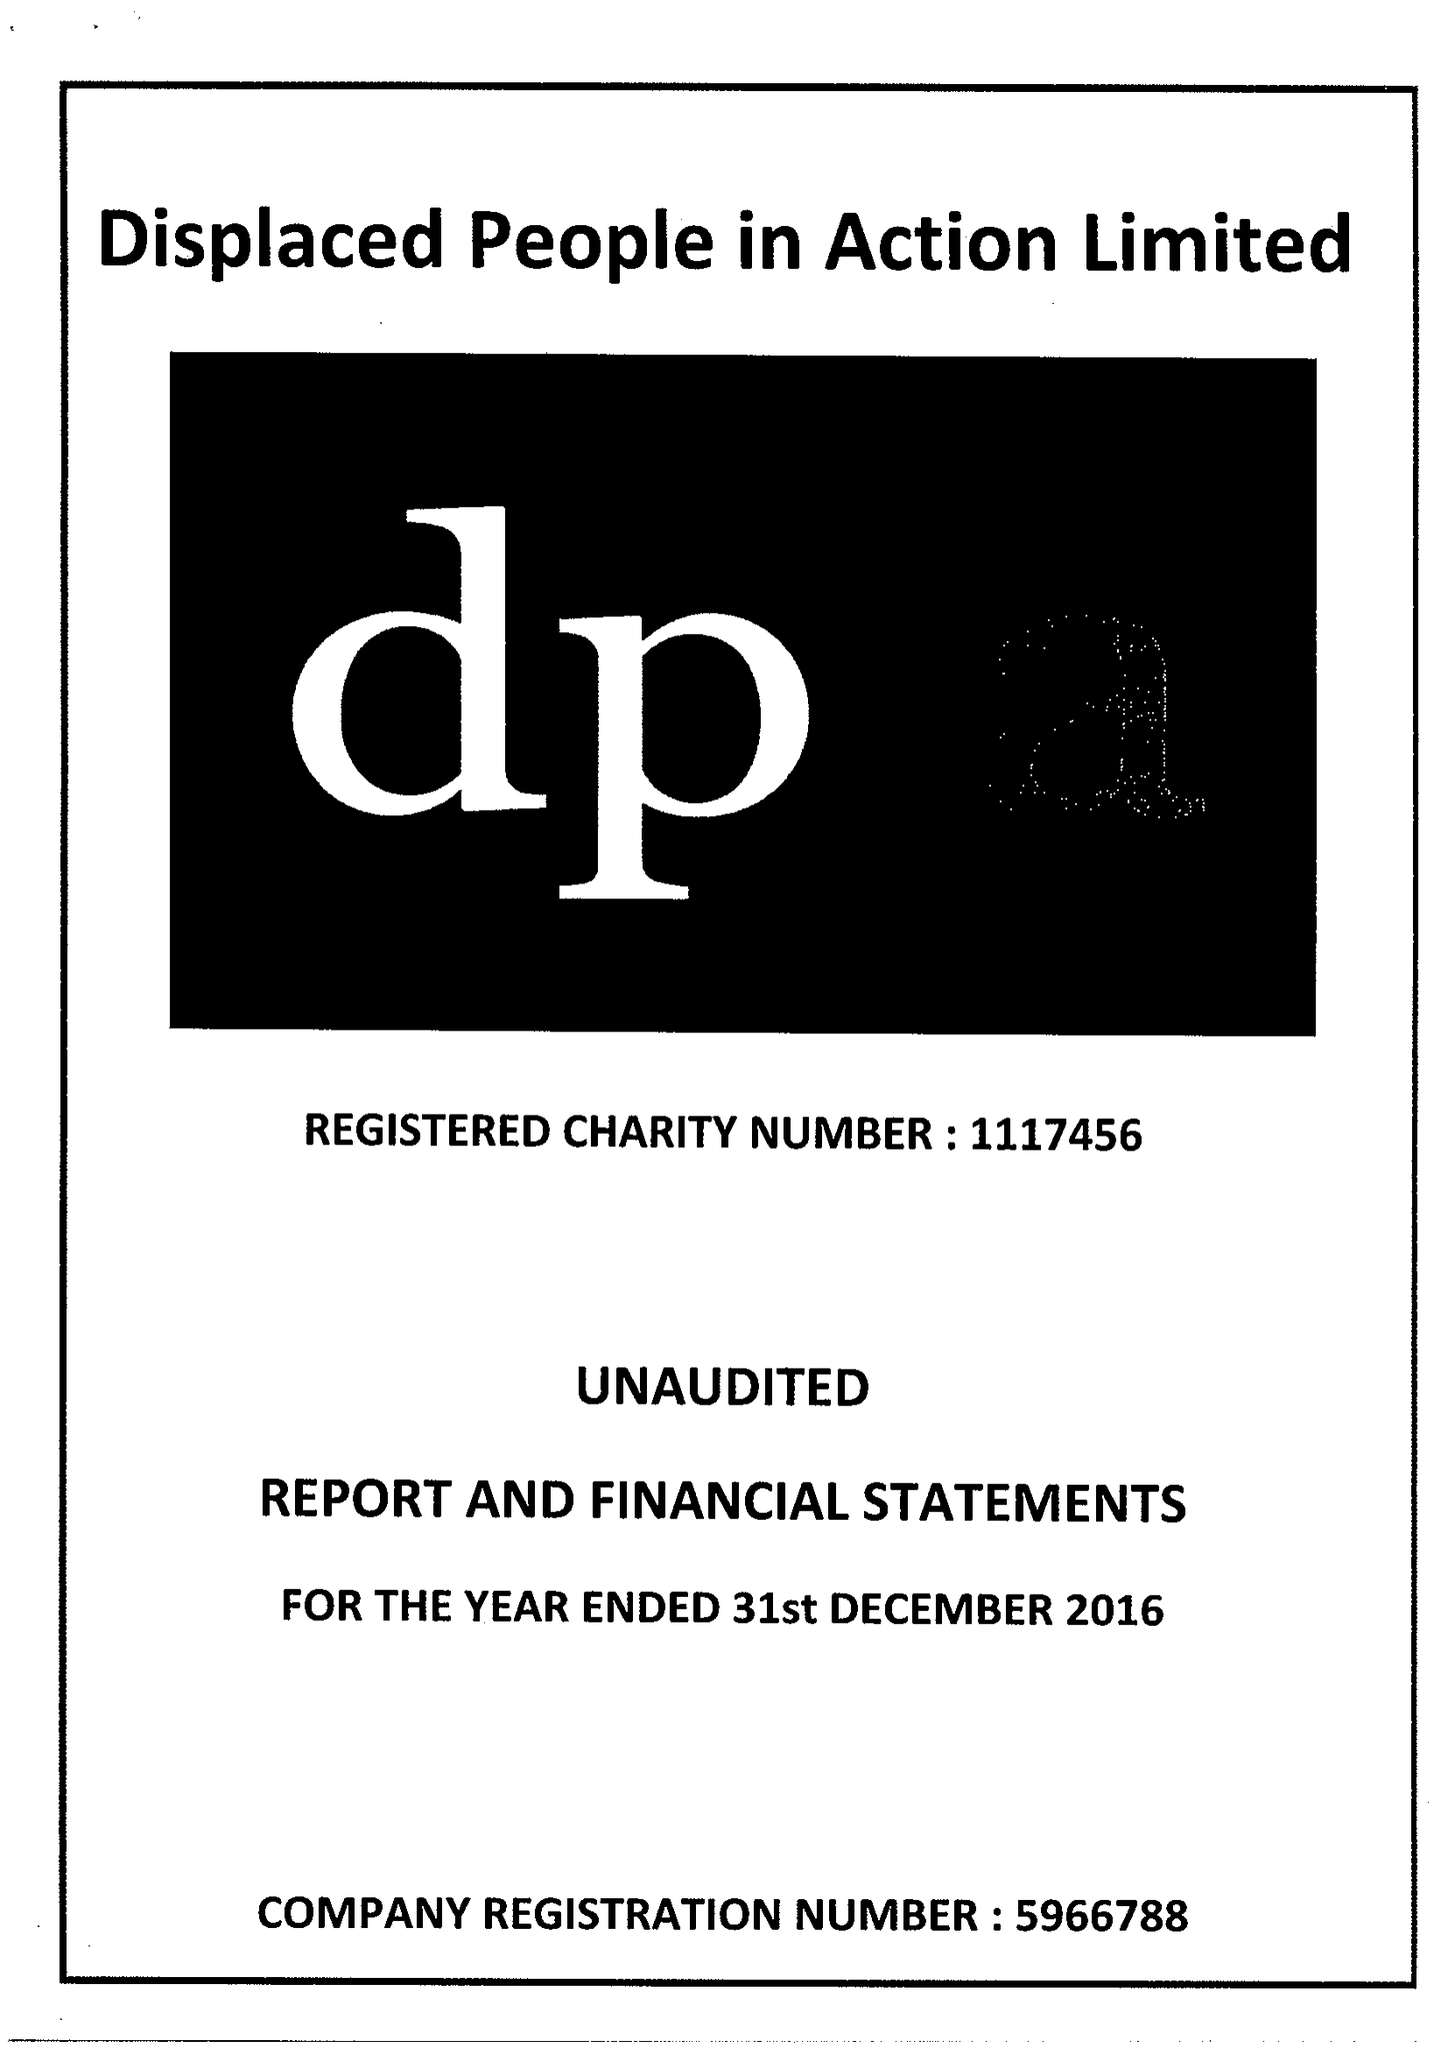What is the value for the report_date?
Answer the question using a single word or phrase. 2016-12-31 